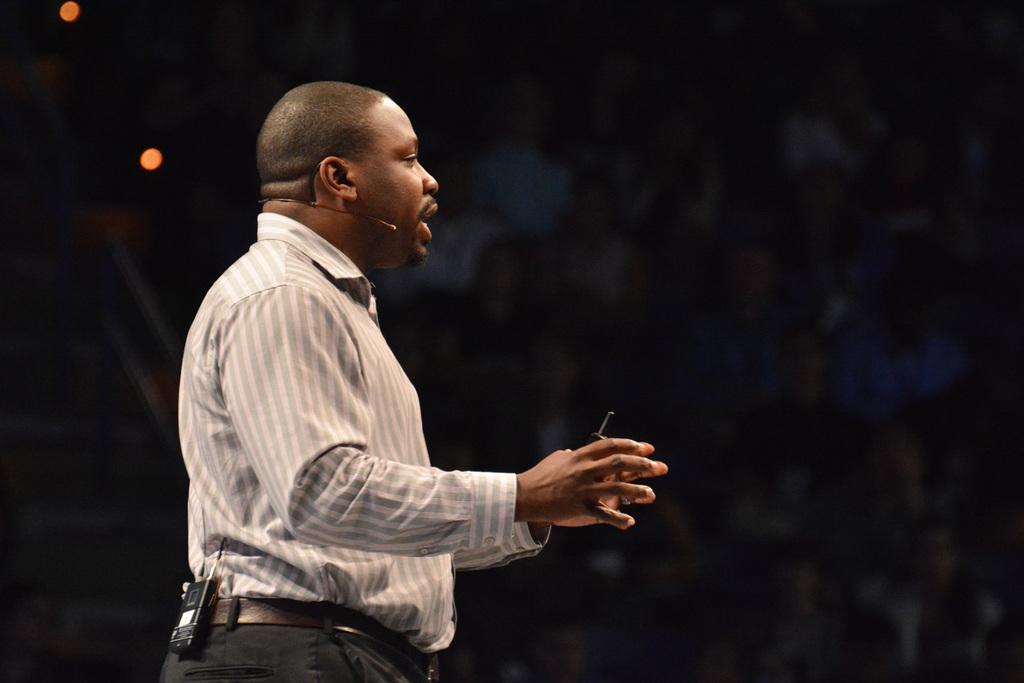Please provide a concise description of this image. In this picture I can see there is a person standing, he has a microphone, he is holding an object in his hand and the backdrop of the image is dark. 